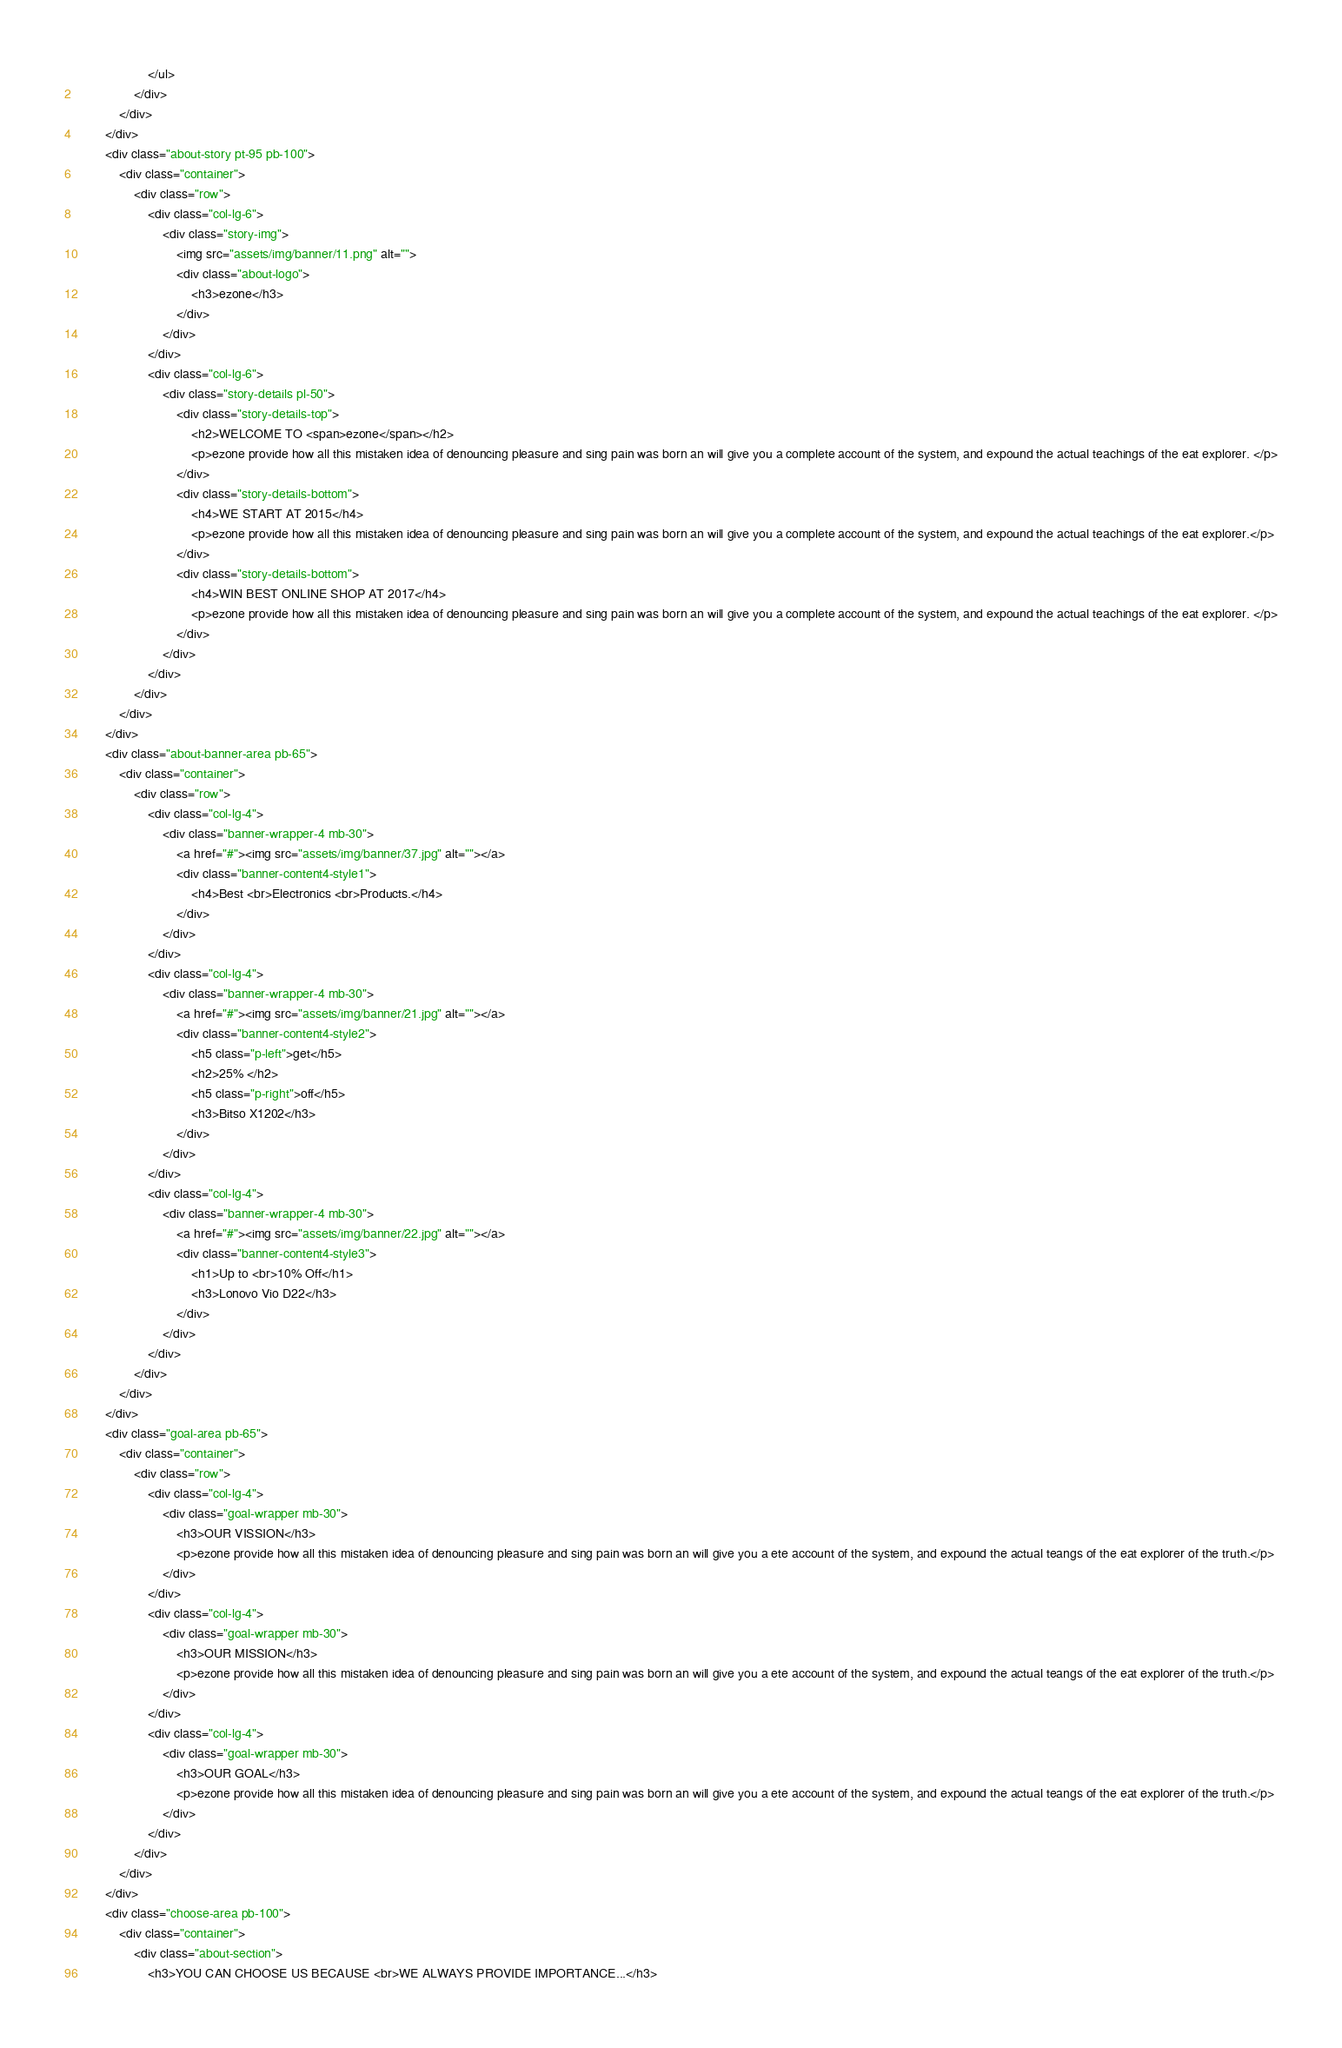Convert code to text. <code><loc_0><loc_0><loc_500><loc_500><_HTML_>                    </ul>
                </div>
            </div>
        </div>
        <div class="about-story pt-95 pb-100">
            <div class="container">
                <div class="row">
                    <div class="col-lg-6">
                        <div class="story-img">
                            <img src="assets/img/banner/11.png" alt="">
                            <div class="about-logo">
                                <h3>ezone</h3>
                            </div>
                        </div>
                    </div>
                    <div class="col-lg-6">
                        <div class="story-details pl-50">
                            <div class="story-details-top">
                                <h2>WELCOME TO <span>ezone</span></h2>
                                <p>ezone provide how all this mistaken idea of denouncing pleasure and sing pain was born an will give you a complete account of the system, and expound the actual teachings of the eat explorer. </p>
                            </div>
                            <div class="story-details-bottom">
                                <h4>WE START AT 2015</h4>
                                <p>ezone provide how all this mistaken idea of denouncing pleasure and sing pain was born an will give you a complete account of the system, and expound the actual teachings of the eat explorer.</p>
                            </div>
                            <div class="story-details-bottom">
                                <h4>WIN BEST ONLINE SHOP AT 2017</h4>
                                <p>ezone provide how all this mistaken idea of denouncing pleasure and sing pain was born an will give you a complete account of the system, and expound the actual teachings of the eat explorer. </p>
                            </div>
                        </div>
                    </div>
                </div>
            </div>
        </div>
        <div class="about-banner-area pb-65">
            <div class="container">
                <div class="row">
                    <div class="col-lg-4">
                        <div class="banner-wrapper-4 mb-30">
                            <a href="#"><img src="assets/img/banner/37.jpg" alt=""></a>
                            <div class="banner-content4-style1">
                                <h4>Best <br>Electronics <br>Products.</h4>
                            </div>
                        </div>
                    </div>
                    <div class="col-lg-4">
                        <div class="banner-wrapper-4 mb-30">
                            <a href="#"><img src="assets/img/banner/21.jpg" alt=""></a>
                            <div class="banner-content4-style2">
                                <h5 class="p-left">get</h5>
                                <h2>25% </h2>
                                <h5 class="p-right">off</h5>
                                <h3>Bitso X1202</h3>
                            </div>
                        </div>
                    </div>
                    <div class="col-lg-4">
                        <div class="banner-wrapper-4 mb-30">
                            <a href="#"><img src="assets/img/banner/22.jpg" alt=""></a>
                            <div class="banner-content4-style3">
                                <h1>Up to <br>10% Off</h1>
                                <h3>Lonovo Vio D22</h3>
                            </div>
                        </div>
                    </div>
                </div>
            </div>
        </div>
        <div class="goal-area pb-65">
            <div class="container">
                <div class="row">
                    <div class="col-lg-4">
                        <div class="goal-wrapper mb-30">
                            <h3>OUR VISSION</h3>
                            <p>ezone provide how all this mistaken idea of denouncing pleasure and sing pain was born an will give you a ete account of the system, and expound the actual teangs of the eat explorer of the truth.</p>
                        </div>
                    </div>
                    <div class="col-lg-4">
                        <div class="goal-wrapper mb-30">
                            <h3>OUR MISSION</h3>
                            <p>ezone provide how all this mistaken idea of denouncing pleasure and sing pain was born an will give you a ete account of the system, and expound the actual teangs of the eat explorer of the truth.</p>
                        </div>
                    </div>
                    <div class="col-lg-4">
                        <div class="goal-wrapper mb-30">
                            <h3>OUR GOAL</h3>
                            <p>ezone provide how all this mistaken idea of denouncing pleasure and sing pain was born an will give you a ete account of the system, and expound the actual teangs of the eat explorer of the truth.</p>
                        </div>
                    </div>
                </div>
            </div>
        </div>
        <div class="choose-area pb-100">
            <div class="container">
                <div class="about-section">
                    <h3>YOU CAN CHOOSE US BECAUSE <br>WE ALWAYS PROVIDE IMPORTANCE...</h3></code> 